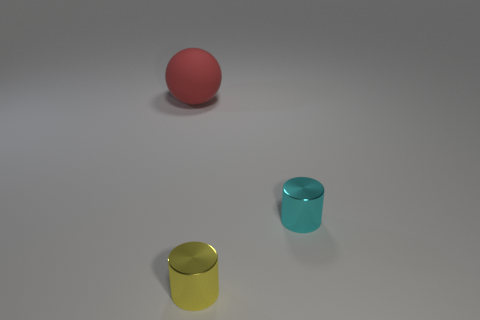How many yellow metallic objects have the same size as the cyan shiny cylinder?
Your answer should be very brief. 1. There is a object that is both in front of the red rubber sphere and behind the yellow thing; what size is it?
Provide a succinct answer. Small. There is a metal cylinder behind the small metal cylinder that is in front of the cyan cylinder; how many small metal cylinders are to the left of it?
Your answer should be very brief. 1. The other metallic thing that is the same size as the yellow metal thing is what color?
Give a very brief answer. Cyan. What is the shape of the small shiny object that is left of the cyan metal object behind the tiny cylinder in front of the cyan cylinder?
Provide a short and direct response. Cylinder. What number of big matte objects are to the left of the small cylinder that is behind the yellow metallic thing?
Keep it short and to the point. 1. There is a small metallic thing behind the yellow thing; does it have the same shape as the small thing that is on the left side of the cyan shiny cylinder?
Keep it short and to the point. Yes. There is a large object; what number of tiny cyan metal cylinders are to the left of it?
Give a very brief answer. 0. Does the object that is behind the small cyan object have the same material as the yellow cylinder?
Keep it short and to the point. No. There is another shiny thing that is the same shape as the tiny cyan metal object; what is its color?
Offer a terse response. Yellow. 